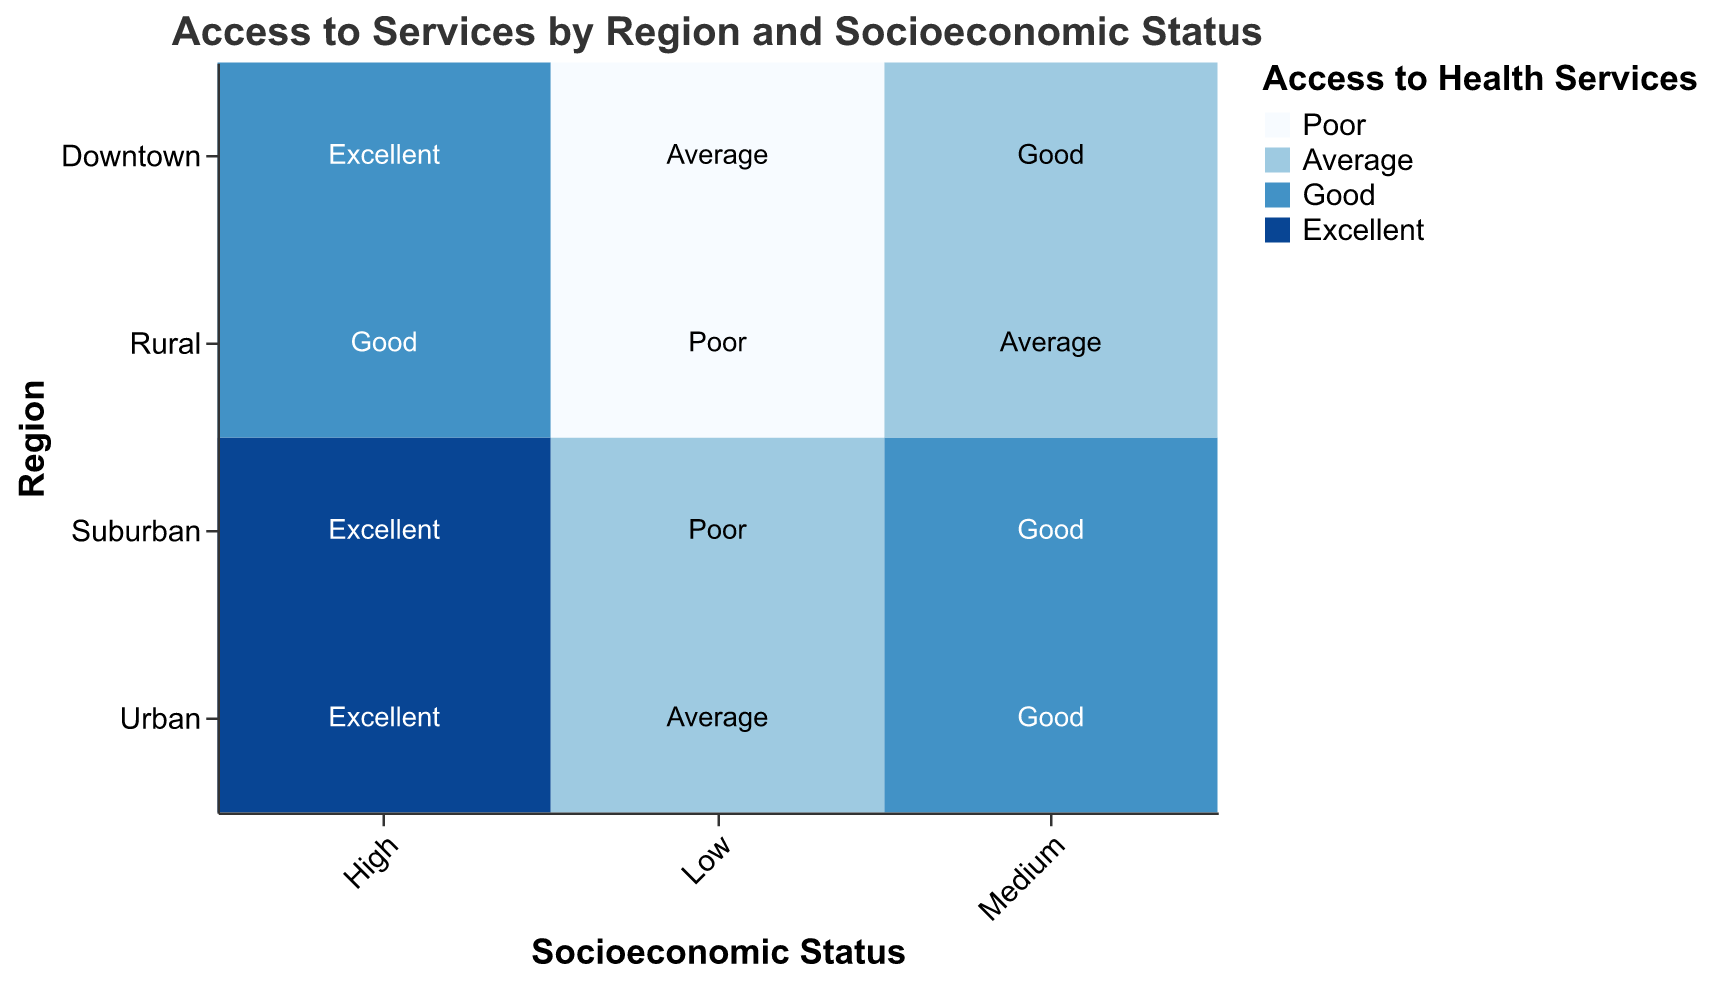What is the title of the heatmap? The title of the heatmap is usually located at the top center of the figure and provides a summary of the chart's purpose.
Answer: Access to Services by Region and Socioeconomic Status Which region has the best access to health services for high socioeconomic status? By checking the color coding in the heatmap, the best access (dark blue) for high socioeconomic status across regions can be identified easily.
Answer: Suburban What is the pattern of access to emergency services in the Downtown region by socioeconomic status? By looking at the text values in the cells corresponding to the Downtown region in the category of Access to Emergency Services, we can identify the pattern for high, medium, and low socioeconomic statuses.
Answer: Excellent for High, Good for Medium, Average for Low In which region is the access to health services poorest for low socioeconomic status? This question requires checking the lowest accessibility (light blue) when the socioeconomic status is low across all regions.
Answer: Rural How does access to health services change by socioeconomic status in Urban region? By observing the color gradient from light to dark as socioeconomic status changes from low to high in the Urban region, we can find the trend.
Answer: Average to Good to Excellent What is the population density in Rural region? The population density for each region can be found in the dataset or by looking for any notes or legends on the chart if present.
Answer: 2000 Which region shows the least variation in access to emergency services across different socioeconomic statuses? By assessing if the text values in a region’s cells for Access to Emergency Services are similar or the same across all socioeconomic statuses.
Answer: Urban Compare access to emergency services in Suburban region to access to health services in the same region. Compare the text labels for emergency services to the color shades representing access to health services in the Suburban region.
Answer: Both Excellent for High, Good for Medium, Poor for Low Is there any region where low socioeconomic status has better access to emergency services than health services? By comparing the light blue and relevant texts for low socioeconomic status across all regions in the Access to Health Services and Access to Emergency Services columns.
Answer: Downtown How does population density affect access to health services in regions with medium socioeconomic status? Evaluate access to health services across different regions keeping both population density and socioeconomic status in context. Medium socioeconomic status and varying population densities (15000 in Downtown, 5000 in Suburban, 2000 in Rural, and 10000 in Urban) need to be examined for their corresponding access ratings.
Answer: Varies from Average (Downtown) to Good (Suburban and Urban) to Average (Rural) 